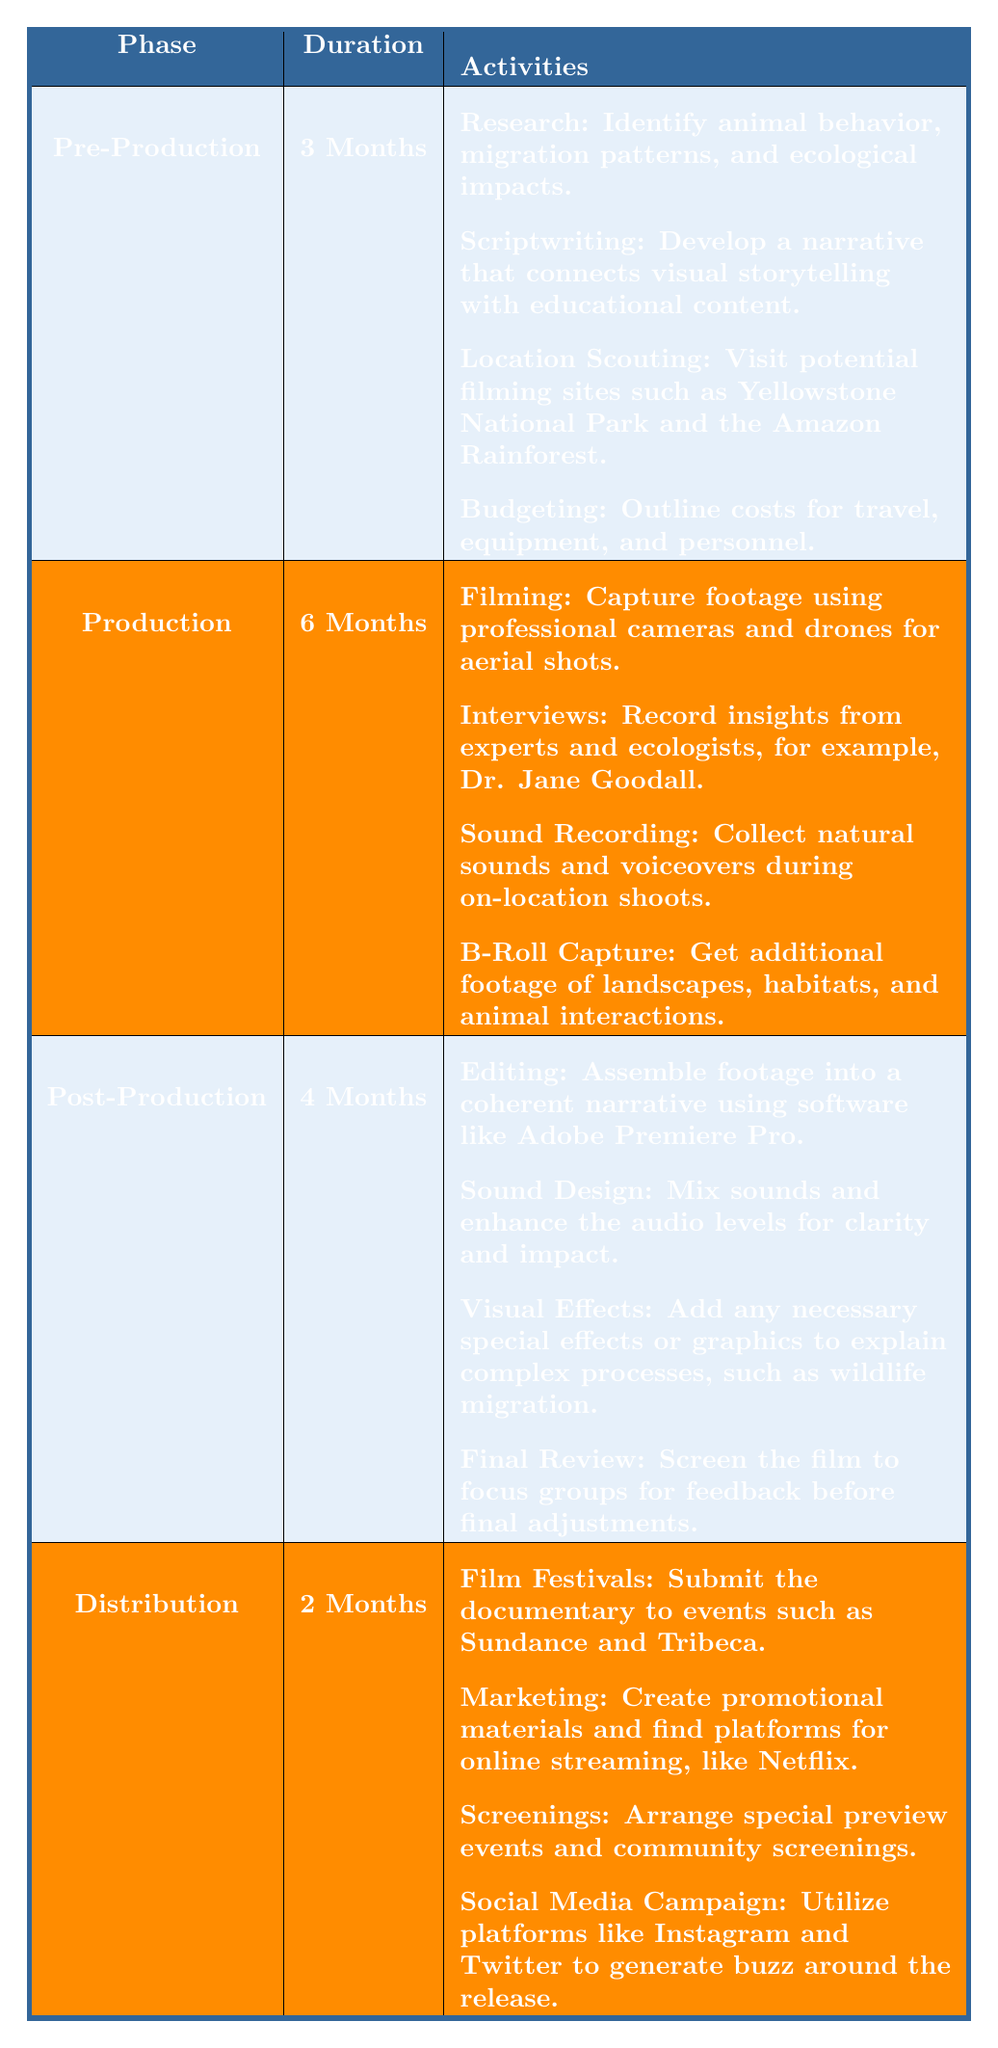What is the duration of the Production phase? The table indicates that the Production phase has a duration listed as **6 Months**.
Answer: 6 Months What activities are involved in the Pre-Production phase? The table lists four activities for the Pre-Production phase: Research, Scriptwriting, Location Scouting, and Budgeting.
Answer: Research, Scriptwriting, Location Scouting, Budgeting How many months is the total duration for the Post-Production and Distribution phases combined? The Post-Production phase lasts **4 Months**, and the Distribution phase lasts **2 Months**. Adding these together gives 4 + 2 = 6 Months.
Answer: 6 Months Is sound recording included in the Production phase? The table lists Sound Recording as one of the activities in the Production phase, confirming that it is included.
Answer: Yes What is the longest phase in the production timeline? By comparing the durations listed, Pre-Production is **3 Months**, Production is **6 Months**, Post-Production is **4 Months**, and Distribution is **2 Months**. The longest phase is Production, with **6 Months**.
Answer: Production What is the total duration of all the phases combined? Adding the durations: Pre-Production (3 Months) + Production (6 Months) + Post-Production (4 Months) + Distribution (2 Months) gives a total of 3 + 6 + 4 + 2 = 15 Months.
Answer: 15 Months Which phase includes activities related to film festivals? The Distribution phase includes the activity of submitting the documentary to film festivals such as Sundance and Tribeca.
Answer: Distribution What percentage of the total production time is dedicated to the Production phase? The total duration is 15 Months. The Production phase lasts 6 Months, so the percentage is (6/15) * 100 = 40%.
Answer: 40% Are there any activities in the Post-Production phase that involve audience interaction? The Final Review activity in the Post-Production phase involves screening the film to focus groups for feedback, indicating audience interaction.
Answer: Yes What activities in the Distribution phase involve marketing? The Distribution phase includes Marketing and Social Media Campaign activities, both of which are focused on promoting the film.
Answer: Marketing, Social Media Campaign 